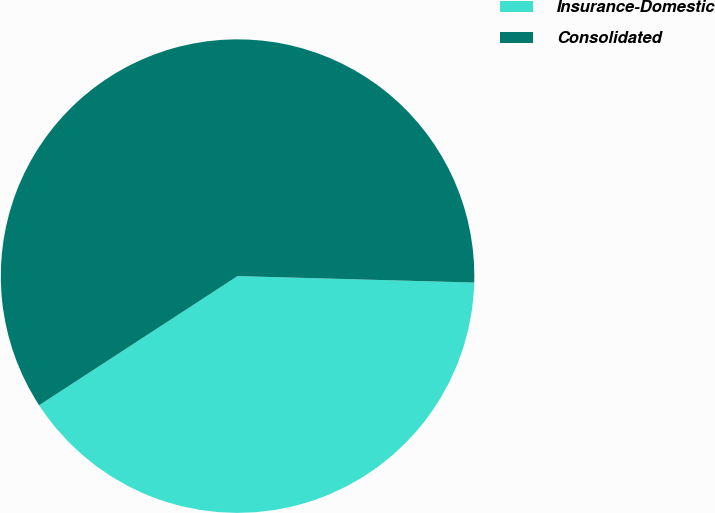Convert chart. <chart><loc_0><loc_0><loc_500><loc_500><pie_chart><fcel>Insurance-Domestic<fcel>Consolidated<nl><fcel>40.38%<fcel>59.62%<nl></chart> 